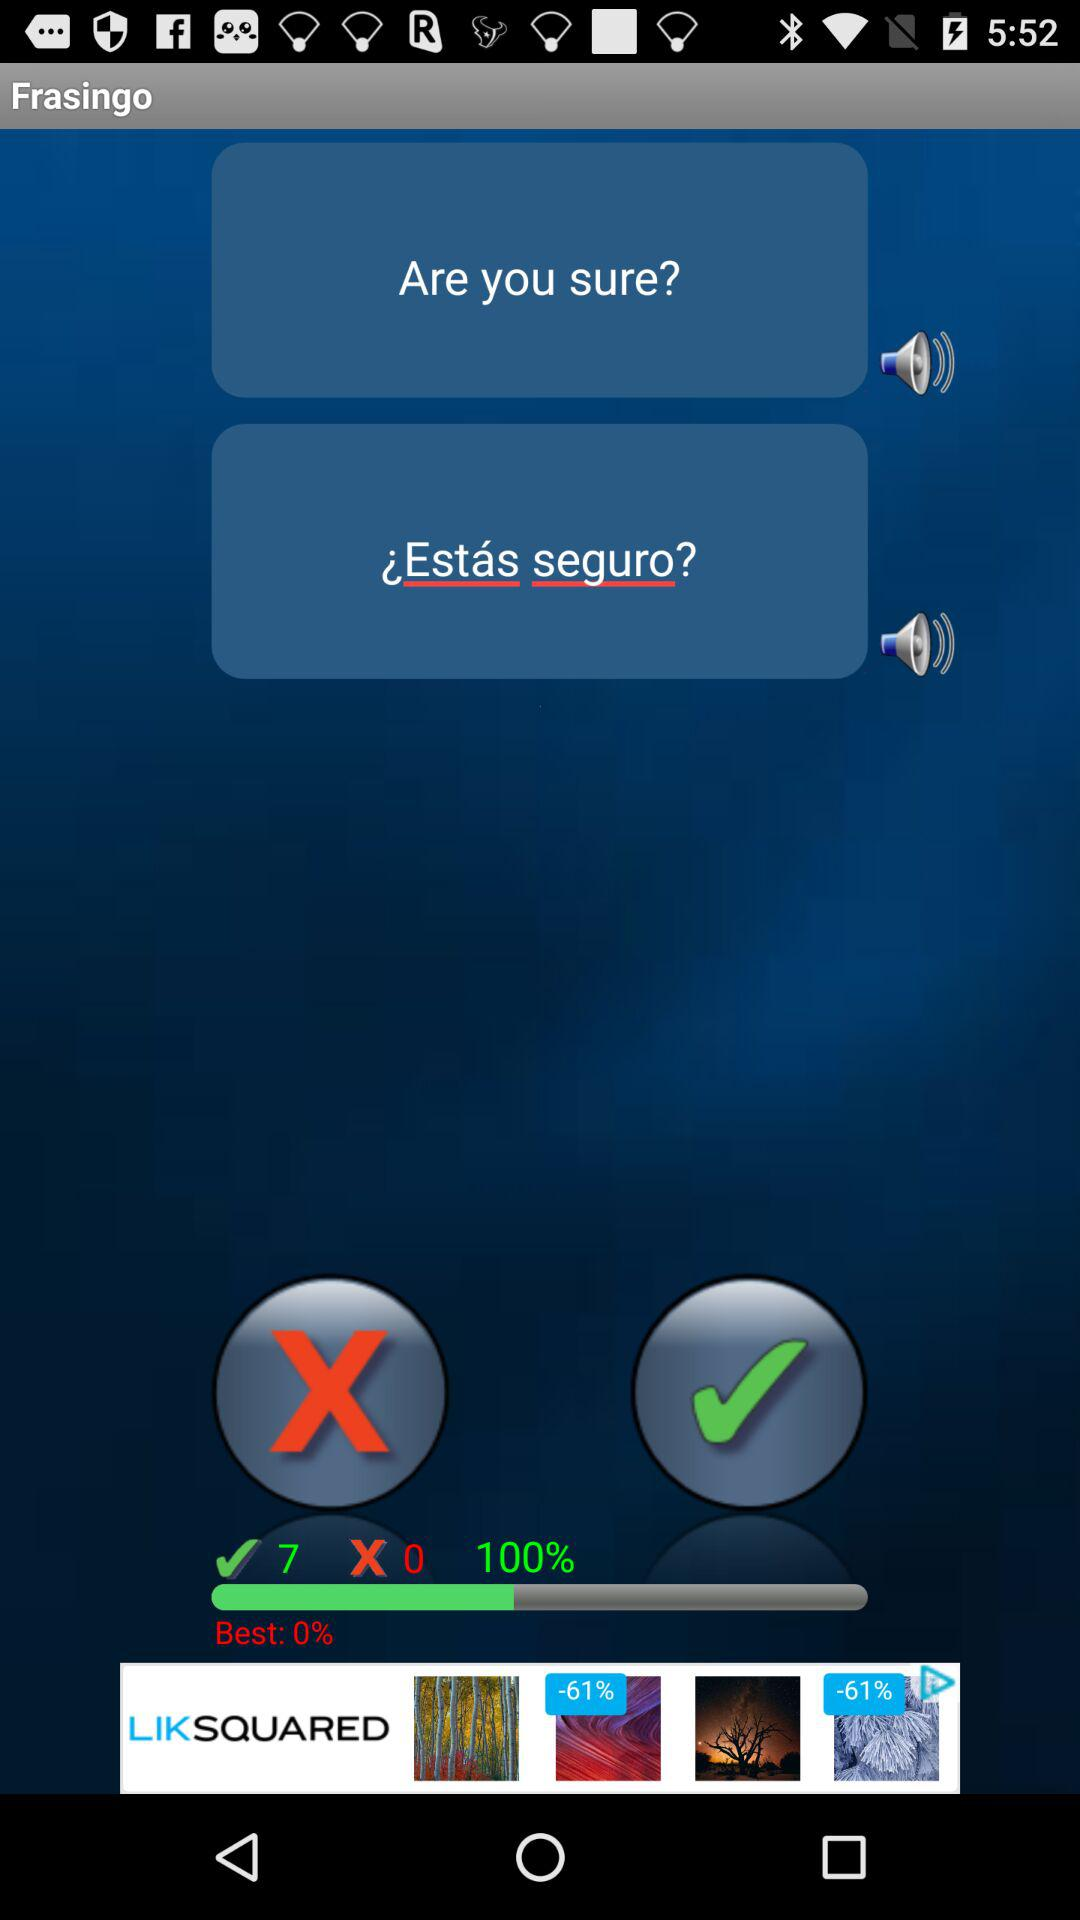What's the "Best" percentage? The "Best" percentage is 0. 